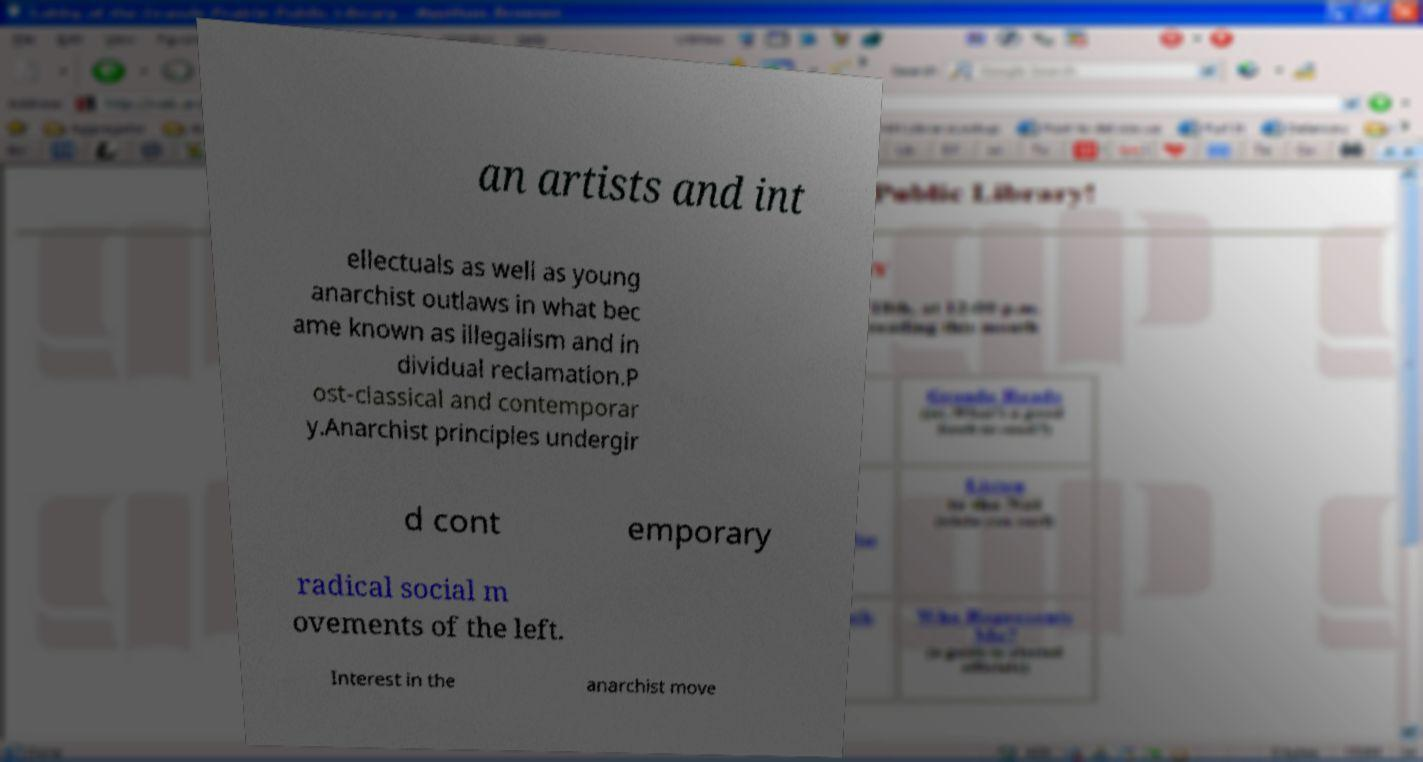What messages or text are displayed in this image? I need them in a readable, typed format. an artists and int ellectuals as well as young anarchist outlaws in what bec ame known as illegalism and in dividual reclamation.P ost-classical and contemporar y.Anarchist principles undergir d cont emporary radical social m ovements of the left. Interest in the anarchist move 